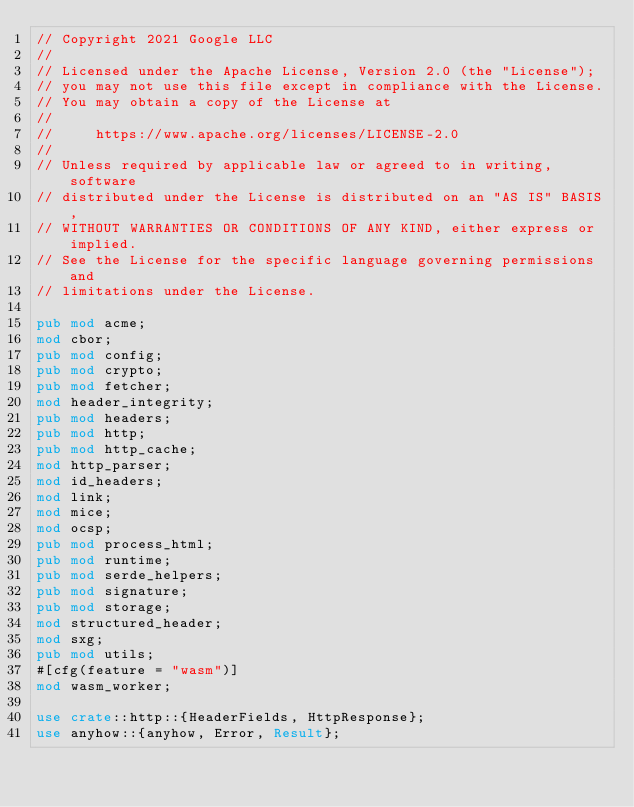Convert code to text. <code><loc_0><loc_0><loc_500><loc_500><_Rust_>// Copyright 2021 Google LLC
//
// Licensed under the Apache License, Version 2.0 (the "License");
// you may not use this file except in compliance with the License.
// You may obtain a copy of the License at
//
//     https://www.apache.org/licenses/LICENSE-2.0
//
// Unless required by applicable law or agreed to in writing, software
// distributed under the License is distributed on an "AS IS" BASIS,
// WITHOUT WARRANTIES OR CONDITIONS OF ANY KIND, either express or implied.
// See the License for the specific language governing permissions and
// limitations under the License.

pub mod acme;
mod cbor;
pub mod config;
pub mod crypto;
pub mod fetcher;
mod header_integrity;
pub mod headers;
pub mod http;
pub mod http_cache;
mod http_parser;
mod id_headers;
mod link;
mod mice;
mod ocsp;
pub mod process_html;
pub mod runtime;
pub mod serde_helpers;
pub mod signature;
pub mod storage;
mod structured_header;
mod sxg;
pub mod utils;
#[cfg(feature = "wasm")]
mod wasm_worker;

use crate::http::{HeaderFields, HttpResponse};
use anyhow::{anyhow, Error, Result};</code> 